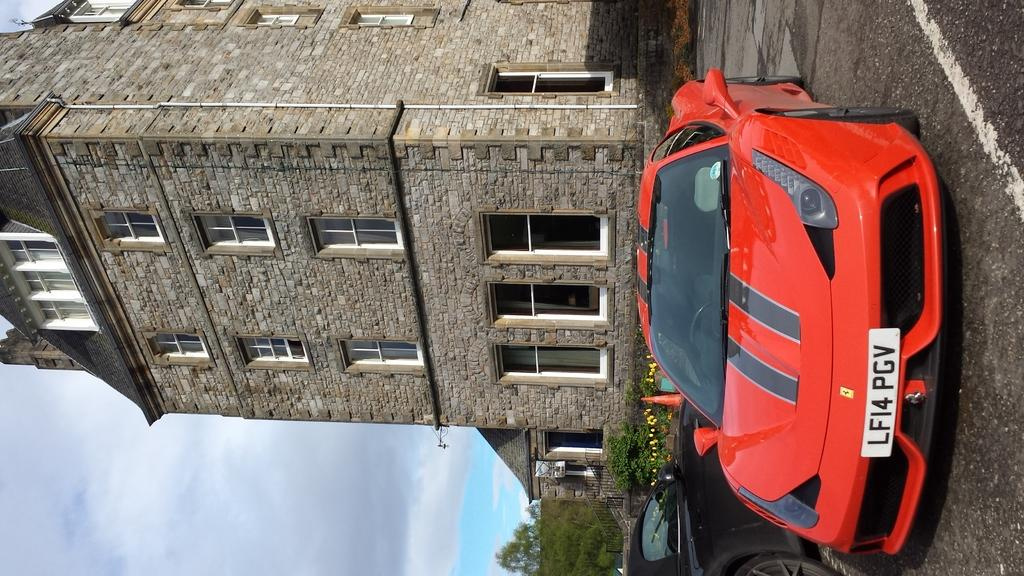What type of transportation can be seen on the road in the image? There are motor vehicles on the road in the image. What natural elements are present in the image? There are plants, trees, and clouds in the image. What architectural features can be seen in the image? There are railings and at least one building in the image. What infrastructure elements are present in the image? There are pipelines in the image. What part of the natural environment is visible in the image? The sky is visible in the image, with clouds present. Can you see a plastic boat floating in the image? There is no boat, plastic or otherwise, visible in the image. How many times does the plastic fall from the sky in the image? There is no plastic falling from the sky in the image. 